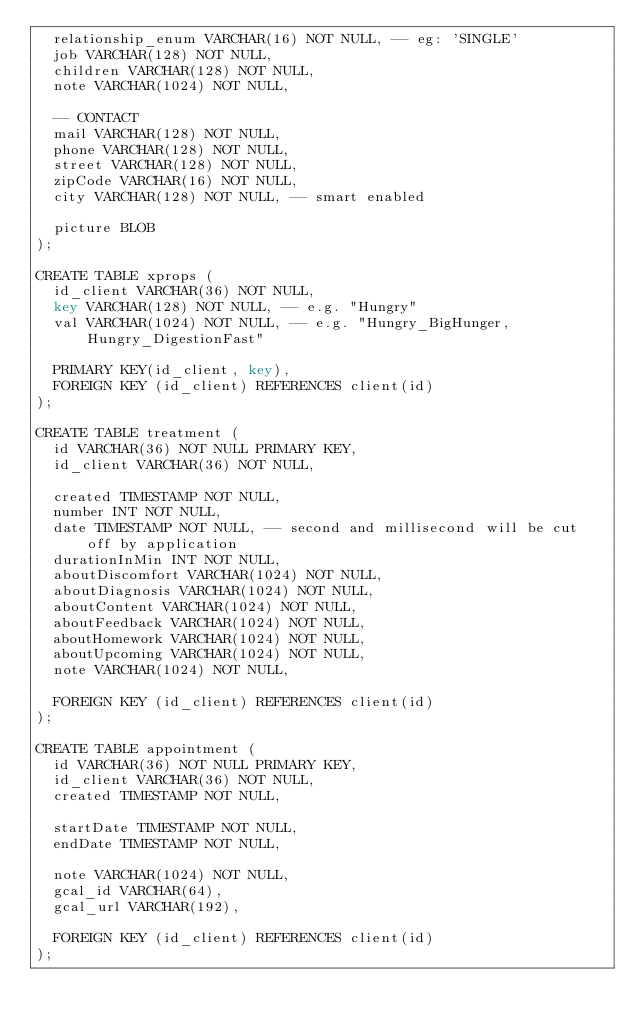Convert code to text. <code><loc_0><loc_0><loc_500><loc_500><_SQL_>  relationship_enum VARCHAR(16) NOT NULL, -- eg: 'SINGLE'
  job VARCHAR(128) NOT NULL,
  children VARCHAR(128) NOT NULL,
  note VARCHAR(1024) NOT NULL,

  -- CONTACT
  mail VARCHAR(128) NOT NULL,
  phone VARCHAR(128) NOT NULL,
  street VARCHAR(128) NOT NULL,
  zipCode VARCHAR(16) NOT NULL,
  city VARCHAR(128) NOT NULL, -- smart enabled

  picture BLOB
);

CREATE TABLE xprops (
  id_client VARCHAR(36) NOT NULL,
  key VARCHAR(128) NOT NULL, -- e.g. "Hungry"
  val VARCHAR(1024) NOT NULL, -- e.g. "Hungry_BigHunger,Hungry_DigestionFast"

  PRIMARY KEY(id_client, key),
  FOREIGN KEY (id_client) REFERENCES client(id)
);

CREATE TABLE treatment (
  id VARCHAR(36) NOT NULL PRIMARY KEY,
  id_client VARCHAR(36) NOT NULL,

  created TIMESTAMP NOT NULL,
  number INT NOT NULL,
  date TIMESTAMP NOT NULL, -- second and millisecond will be cut off by application
  durationInMin INT NOT NULL,
  aboutDiscomfort VARCHAR(1024) NOT NULL,
  aboutDiagnosis VARCHAR(1024) NOT NULL,
  aboutContent VARCHAR(1024) NOT NULL,
  aboutFeedback VARCHAR(1024) NOT NULL,
  aboutHomework VARCHAR(1024) NOT NULL,
  aboutUpcoming VARCHAR(1024) NOT NULL,
  note VARCHAR(1024) NOT NULL,

  FOREIGN KEY (id_client) REFERENCES client(id)
);

CREATE TABLE appointment (
  id VARCHAR(36) NOT NULL PRIMARY KEY,
  id_client VARCHAR(36) NOT NULL,
  created TIMESTAMP NOT NULL,

  startDate TIMESTAMP NOT NULL,
  endDate TIMESTAMP NOT NULL,

  note VARCHAR(1024) NOT NULL,
  gcal_id VARCHAR(64),
  gcal_url VARCHAR(192),

  FOREIGN KEY (id_client) REFERENCES client(id)
);
</code> 